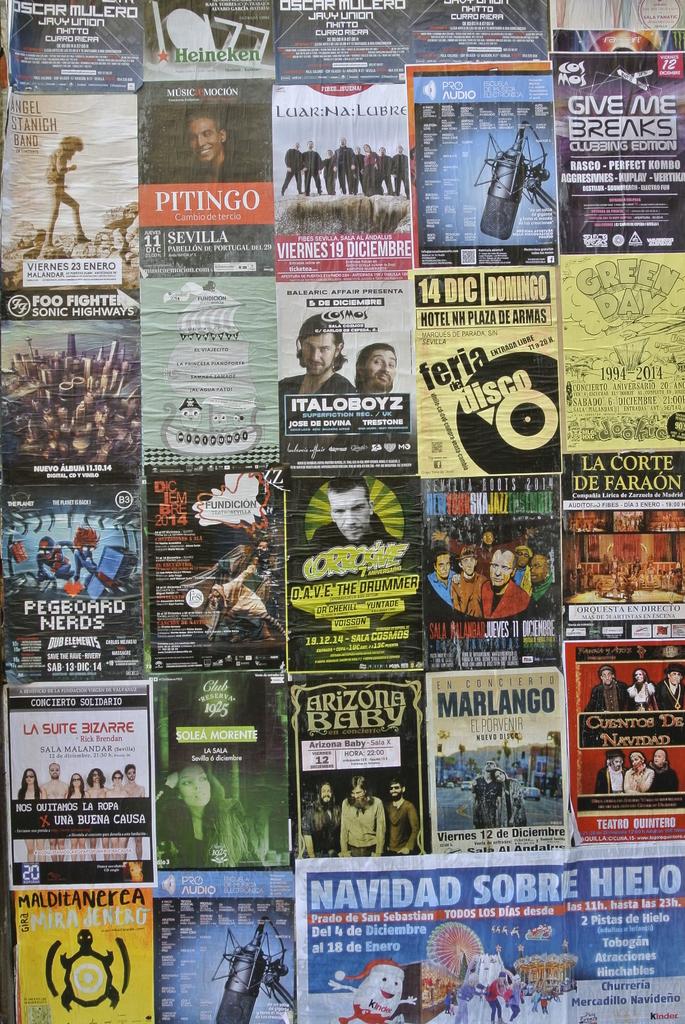What does the add on the bottom right say?
Give a very brief answer. Navidad sobre hielo. What years are listed on the green day ad?
Offer a terse response. 1994-2014. 